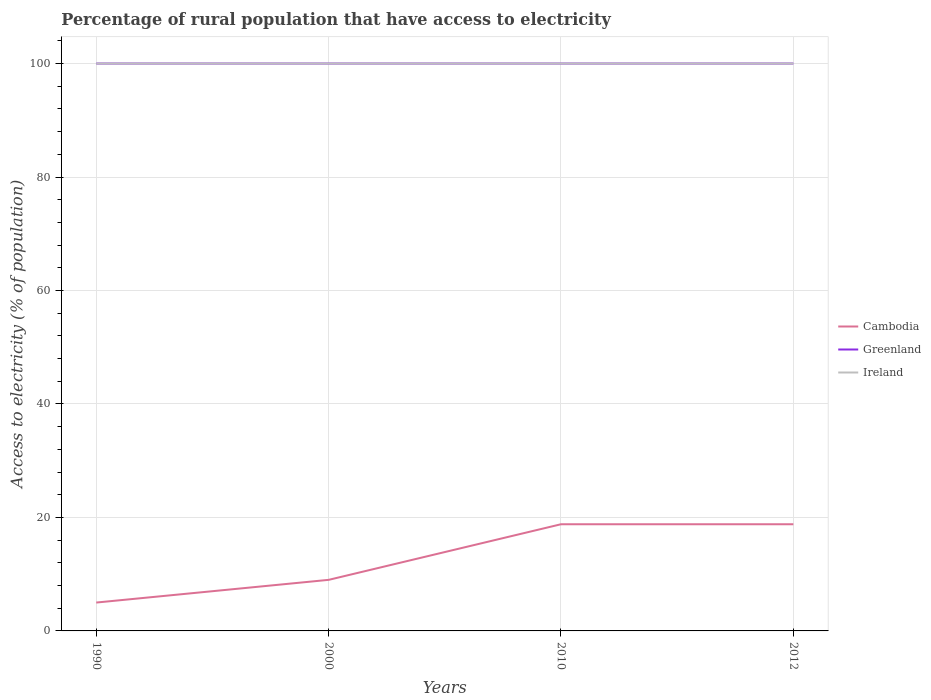Does the line corresponding to Cambodia intersect with the line corresponding to Ireland?
Ensure brevity in your answer.  No. Is the number of lines equal to the number of legend labels?
Provide a short and direct response. Yes. In which year was the percentage of rural population that have access to electricity in Greenland maximum?
Give a very brief answer. 1990. What is the total percentage of rural population that have access to electricity in Ireland in the graph?
Keep it short and to the point. 0. What is the difference between the highest and the lowest percentage of rural population that have access to electricity in Cambodia?
Your answer should be very brief. 2. What is the difference between two consecutive major ticks on the Y-axis?
Ensure brevity in your answer.  20. Are the values on the major ticks of Y-axis written in scientific E-notation?
Your response must be concise. No. Does the graph contain any zero values?
Provide a succinct answer. No. What is the title of the graph?
Keep it short and to the point. Percentage of rural population that have access to electricity. What is the label or title of the Y-axis?
Offer a very short reply. Access to electricity (% of population). What is the Access to electricity (% of population) in Cambodia in 1990?
Offer a very short reply. 5. What is the Access to electricity (% of population) of Ireland in 1990?
Make the answer very short. 100. What is the Access to electricity (% of population) of Cambodia in 2000?
Your answer should be very brief. 9. What is the Access to electricity (% of population) in Greenland in 2010?
Make the answer very short. 100. What is the Access to electricity (% of population) in Greenland in 2012?
Provide a succinct answer. 100. What is the Access to electricity (% of population) in Ireland in 2012?
Make the answer very short. 100. Across all years, what is the maximum Access to electricity (% of population) of Greenland?
Offer a very short reply. 100. Across all years, what is the maximum Access to electricity (% of population) in Ireland?
Give a very brief answer. 100. Across all years, what is the minimum Access to electricity (% of population) of Cambodia?
Ensure brevity in your answer.  5. Across all years, what is the minimum Access to electricity (% of population) of Greenland?
Offer a terse response. 100. Across all years, what is the minimum Access to electricity (% of population) in Ireland?
Provide a succinct answer. 100. What is the total Access to electricity (% of population) of Cambodia in the graph?
Your answer should be compact. 51.6. What is the total Access to electricity (% of population) in Ireland in the graph?
Your response must be concise. 400. What is the difference between the Access to electricity (% of population) of Ireland in 1990 and that in 2000?
Offer a very short reply. 0. What is the difference between the Access to electricity (% of population) in Greenland in 1990 and that in 2010?
Keep it short and to the point. 0. What is the difference between the Access to electricity (% of population) of Greenland in 1990 and that in 2012?
Ensure brevity in your answer.  0. What is the difference between the Access to electricity (% of population) in Greenland in 2000 and that in 2010?
Make the answer very short. 0. What is the difference between the Access to electricity (% of population) of Ireland in 2000 and that in 2010?
Ensure brevity in your answer.  0. What is the difference between the Access to electricity (% of population) of Cambodia in 2000 and that in 2012?
Ensure brevity in your answer.  -9.8. What is the difference between the Access to electricity (% of population) of Greenland in 2000 and that in 2012?
Ensure brevity in your answer.  0. What is the difference between the Access to electricity (% of population) in Ireland in 2000 and that in 2012?
Provide a succinct answer. 0. What is the difference between the Access to electricity (% of population) in Greenland in 2010 and that in 2012?
Your response must be concise. 0. What is the difference between the Access to electricity (% of population) in Cambodia in 1990 and the Access to electricity (% of population) in Greenland in 2000?
Your answer should be compact. -95. What is the difference between the Access to electricity (% of population) in Cambodia in 1990 and the Access to electricity (% of population) in Ireland in 2000?
Provide a succinct answer. -95. What is the difference between the Access to electricity (% of population) in Greenland in 1990 and the Access to electricity (% of population) in Ireland in 2000?
Keep it short and to the point. 0. What is the difference between the Access to electricity (% of population) in Cambodia in 1990 and the Access to electricity (% of population) in Greenland in 2010?
Make the answer very short. -95. What is the difference between the Access to electricity (% of population) of Cambodia in 1990 and the Access to electricity (% of population) of Ireland in 2010?
Your answer should be very brief. -95. What is the difference between the Access to electricity (% of population) in Greenland in 1990 and the Access to electricity (% of population) in Ireland in 2010?
Offer a very short reply. 0. What is the difference between the Access to electricity (% of population) in Cambodia in 1990 and the Access to electricity (% of population) in Greenland in 2012?
Your response must be concise. -95. What is the difference between the Access to electricity (% of population) of Cambodia in 1990 and the Access to electricity (% of population) of Ireland in 2012?
Provide a short and direct response. -95. What is the difference between the Access to electricity (% of population) in Cambodia in 2000 and the Access to electricity (% of population) in Greenland in 2010?
Provide a succinct answer. -91. What is the difference between the Access to electricity (% of population) of Cambodia in 2000 and the Access to electricity (% of population) of Ireland in 2010?
Provide a short and direct response. -91. What is the difference between the Access to electricity (% of population) of Greenland in 2000 and the Access to electricity (% of population) of Ireland in 2010?
Ensure brevity in your answer.  0. What is the difference between the Access to electricity (% of population) of Cambodia in 2000 and the Access to electricity (% of population) of Greenland in 2012?
Provide a succinct answer. -91. What is the difference between the Access to electricity (% of population) of Cambodia in 2000 and the Access to electricity (% of population) of Ireland in 2012?
Offer a very short reply. -91. What is the difference between the Access to electricity (% of population) of Cambodia in 2010 and the Access to electricity (% of population) of Greenland in 2012?
Make the answer very short. -81.2. What is the difference between the Access to electricity (% of population) of Cambodia in 2010 and the Access to electricity (% of population) of Ireland in 2012?
Offer a very short reply. -81.2. What is the average Access to electricity (% of population) in Greenland per year?
Provide a short and direct response. 100. What is the average Access to electricity (% of population) of Ireland per year?
Your answer should be very brief. 100. In the year 1990, what is the difference between the Access to electricity (% of population) in Cambodia and Access to electricity (% of population) in Greenland?
Keep it short and to the point. -95. In the year 1990, what is the difference between the Access to electricity (% of population) in Cambodia and Access to electricity (% of population) in Ireland?
Your answer should be compact. -95. In the year 1990, what is the difference between the Access to electricity (% of population) in Greenland and Access to electricity (% of population) in Ireland?
Provide a succinct answer. 0. In the year 2000, what is the difference between the Access to electricity (% of population) in Cambodia and Access to electricity (% of population) in Greenland?
Provide a short and direct response. -91. In the year 2000, what is the difference between the Access to electricity (% of population) in Cambodia and Access to electricity (% of population) in Ireland?
Make the answer very short. -91. In the year 2000, what is the difference between the Access to electricity (% of population) in Greenland and Access to electricity (% of population) in Ireland?
Your answer should be very brief. 0. In the year 2010, what is the difference between the Access to electricity (% of population) in Cambodia and Access to electricity (% of population) in Greenland?
Ensure brevity in your answer.  -81.2. In the year 2010, what is the difference between the Access to electricity (% of population) in Cambodia and Access to electricity (% of population) in Ireland?
Your answer should be compact. -81.2. In the year 2012, what is the difference between the Access to electricity (% of population) of Cambodia and Access to electricity (% of population) of Greenland?
Provide a short and direct response. -81.2. In the year 2012, what is the difference between the Access to electricity (% of population) in Cambodia and Access to electricity (% of population) in Ireland?
Keep it short and to the point. -81.2. In the year 2012, what is the difference between the Access to electricity (% of population) in Greenland and Access to electricity (% of population) in Ireland?
Your answer should be compact. 0. What is the ratio of the Access to electricity (% of population) in Cambodia in 1990 to that in 2000?
Make the answer very short. 0.56. What is the ratio of the Access to electricity (% of population) of Cambodia in 1990 to that in 2010?
Your answer should be compact. 0.27. What is the ratio of the Access to electricity (% of population) in Greenland in 1990 to that in 2010?
Offer a very short reply. 1. What is the ratio of the Access to electricity (% of population) in Cambodia in 1990 to that in 2012?
Make the answer very short. 0.27. What is the ratio of the Access to electricity (% of population) in Greenland in 1990 to that in 2012?
Your response must be concise. 1. What is the ratio of the Access to electricity (% of population) in Ireland in 1990 to that in 2012?
Provide a short and direct response. 1. What is the ratio of the Access to electricity (% of population) in Cambodia in 2000 to that in 2010?
Ensure brevity in your answer.  0.48. What is the ratio of the Access to electricity (% of population) of Ireland in 2000 to that in 2010?
Keep it short and to the point. 1. What is the ratio of the Access to electricity (% of population) of Cambodia in 2000 to that in 2012?
Make the answer very short. 0.48. What is the ratio of the Access to electricity (% of population) in Greenland in 2000 to that in 2012?
Provide a short and direct response. 1. What is the ratio of the Access to electricity (% of population) of Cambodia in 2010 to that in 2012?
Offer a terse response. 1. What is the ratio of the Access to electricity (% of population) of Greenland in 2010 to that in 2012?
Offer a very short reply. 1. What is the ratio of the Access to electricity (% of population) of Ireland in 2010 to that in 2012?
Provide a short and direct response. 1. What is the difference between the highest and the lowest Access to electricity (% of population) of Greenland?
Give a very brief answer. 0. What is the difference between the highest and the lowest Access to electricity (% of population) of Ireland?
Provide a short and direct response. 0. 